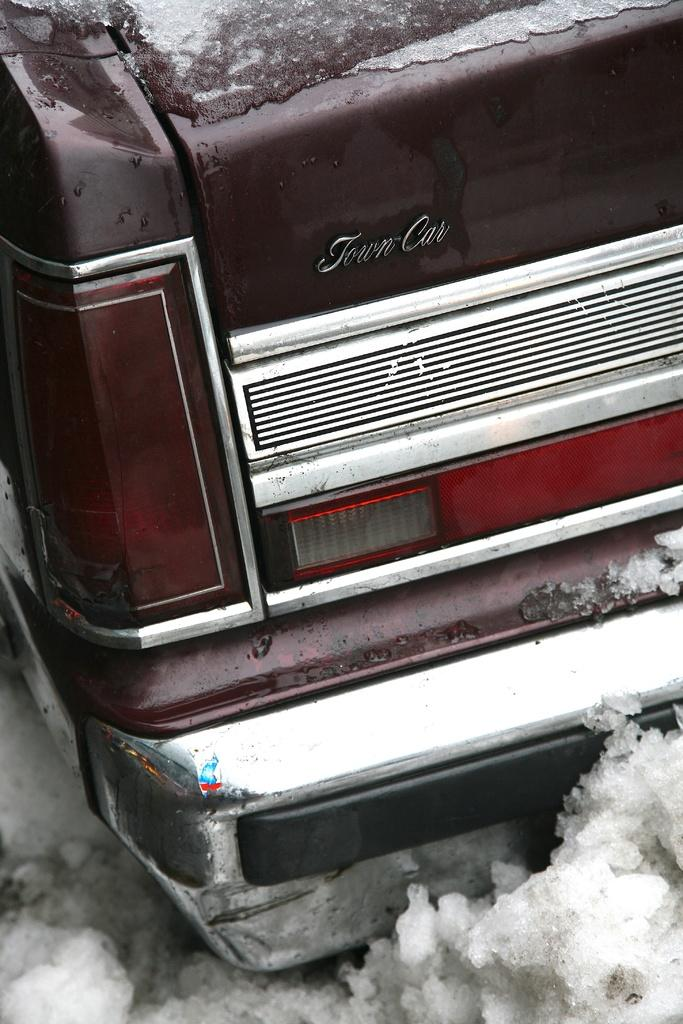Where was the image taken? The image is taken outdoors. What is visible at the bottom of the image? There is snow at the bottom of the image. What is the main subject in the middle of the image? There is a car in the middle of the image. How is the car affected by the snow? The car is covered with snow. What type of attraction can be seen in the image? There is no attraction present in the image; it features a car covered with snow in an outdoor setting with snow at the bottom. What reward is the car receiving for being covered in snow? There is no reward being given to the car for being covered in snow; it is simply a result of the snowy environment. 